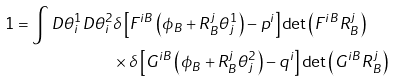Convert formula to latex. <formula><loc_0><loc_0><loc_500><loc_500>1 = \int D \theta _ { i } ^ { 1 } D \theta _ { i } ^ { 2 } & \delta \left [ F ^ { i B } \left ( \phi _ { B } + R _ { B } ^ { j } \theta ^ { 1 } _ { j } \right ) - p ^ { i } \right ] \det \left ( F ^ { i B } R _ { B } ^ { j } \right ) \\ & \times \delta \left [ G ^ { i B } \left ( \phi _ { B } + R _ { B } ^ { j } \theta ^ { 2 } _ { j } \right ) - q ^ { i } \right ] \det \left ( G ^ { i B } R _ { B } ^ { j } \right )</formula> 